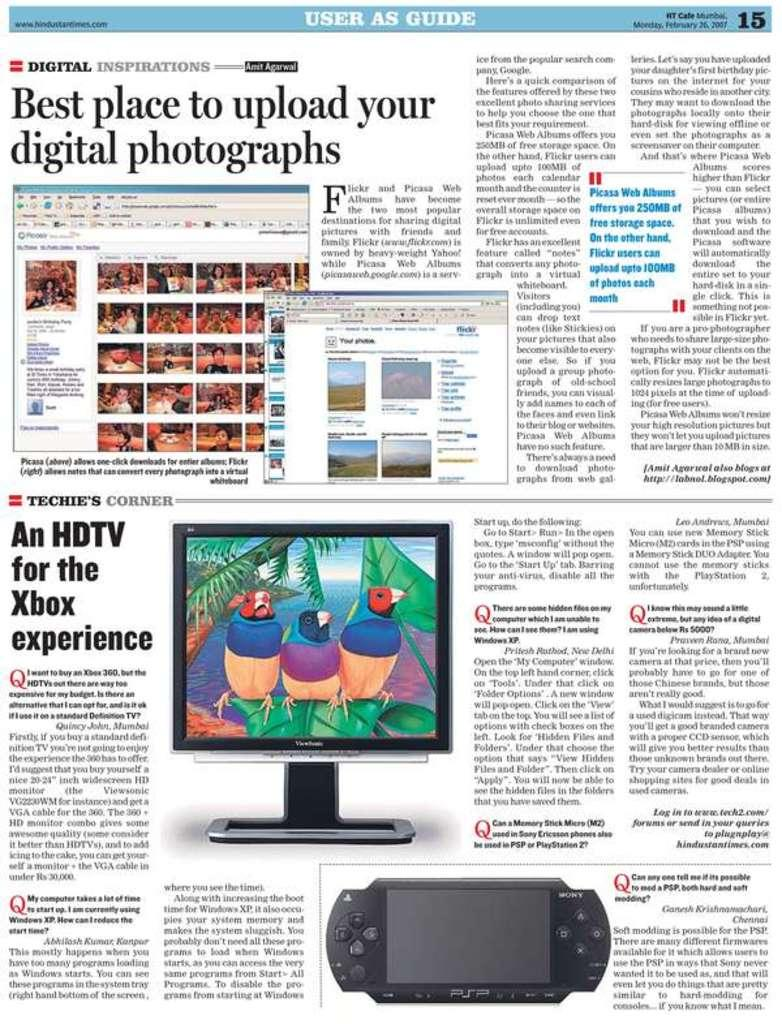<image>
Present a compact description of the photo's key features. an HDTV ad that is on some paper 